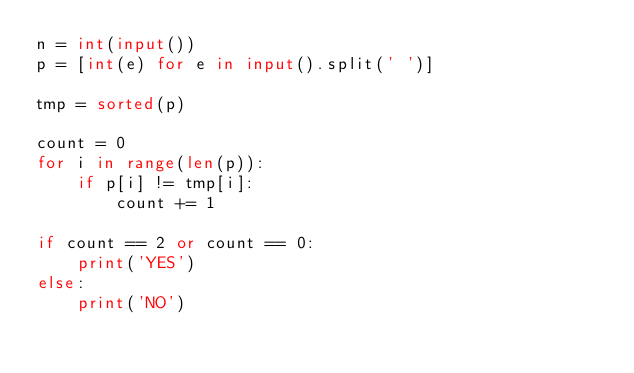Convert code to text. <code><loc_0><loc_0><loc_500><loc_500><_Python_>n = int(input())
p = [int(e) for e in input().split(' ')]

tmp = sorted(p)

count = 0
for i in range(len(p)):
    if p[i] != tmp[i]:
        count += 1

if count == 2 or count == 0:
    print('YES')
else:
    print('NO')

</code> 